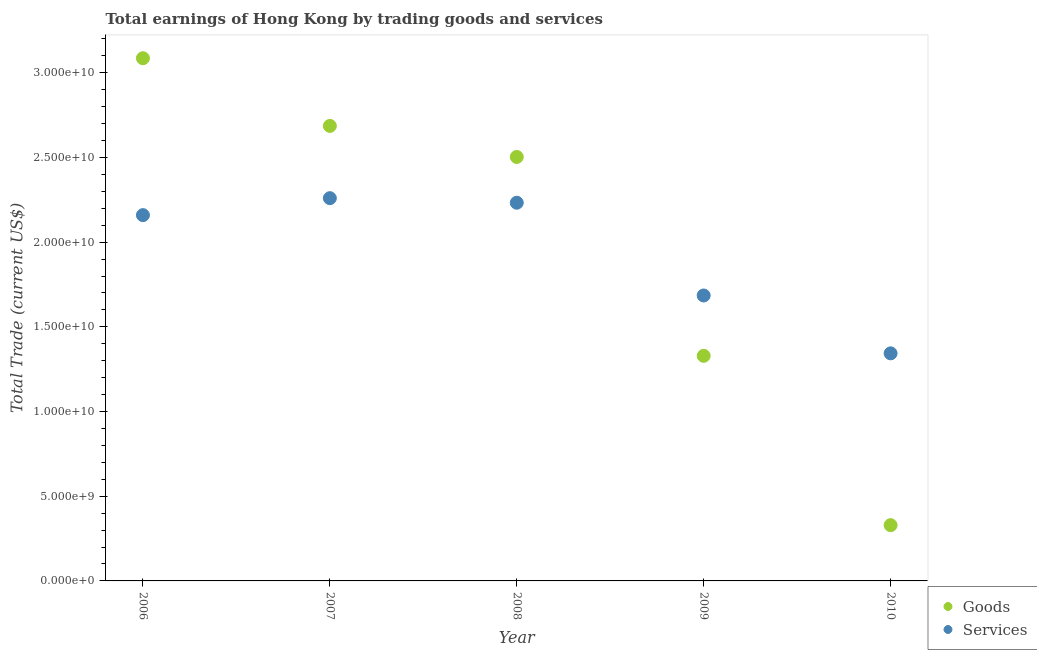What is the amount earned by trading services in 2010?
Your answer should be very brief. 1.34e+1. Across all years, what is the maximum amount earned by trading services?
Keep it short and to the point. 2.26e+1. Across all years, what is the minimum amount earned by trading services?
Your response must be concise. 1.34e+1. In which year was the amount earned by trading goods minimum?
Your answer should be compact. 2010. What is the total amount earned by trading goods in the graph?
Offer a very short reply. 9.93e+1. What is the difference between the amount earned by trading goods in 2008 and that in 2009?
Offer a very short reply. 1.17e+1. What is the difference between the amount earned by trading goods in 2010 and the amount earned by trading services in 2008?
Offer a terse response. -1.90e+1. What is the average amount earned by trading services per year?
Make the answer very short. 1.94e+1. In the year 2007, what is the difference between the amount earned by trading services and amount earned by trading goods?
Ensure brevity in your answer.  -4.27e+09. In how many years, is the amount earned by trading services greater than 5000000000 US$?
Your answer should be compact. 5. What is the ratio of the amount earned by trading goods in 2009 to that in 2010?
Provide a short and direct response. 4.04. What is the difference between the highest and the second highest amount earned by trading goods?
Offer a terse response. 4.00e+09. What is the difference between the highest and the lowest amount earned by trading services?
Provide a short and direct response. 9.16e+09. Is the sum of the amount earned by trading goods in 2008 and 2009 greater than the maximum amount earned by trading services across all years?
Your answer should be compact. Yes. Is the amount earned by trading goods strictly less than the amount earned by trading services over the years?
Keep it short and to the point. No. How many years are there in the graph?
Your response must be concise. 5. What is the difference between two consecutive major ticks on the Y-axis?
Your answer should be compact. 5.00e+09. Does the graph contain grids?
Your response must be concise. No. What is the title of the graph?
Offer a terse response. Total earnings of Hong Kong by trading goods and services. What is the label or title of the Y-axis?
Your response must be concise. Total Trade (current US$). What is the Total Trade (current US$) in Goods in 2006?
Your answer should be compact. 3.09e+1. What is the Total Trade (current US$) in Services in 2006?
Give a very brief answer. 2.16e+1. What is the Total Trade (current US$) in Goods in 2007?
Offer a terse response. 2.69e+1. What is the Total Trade (current US$) in Services in 2007?
Give a very brief answer. 2.26e+1. What is the Total Trade (current US$) in Goods in 2008?
Provide a short and direct response. 2.50e+1. What is the Total Trade (current US$) of Services in 2008?
Make the answer very short. 2.23e+1. What is the Total Trade (current US$) of Goods in 2009?
Make the answer very short. 1.33e+1. What is the Total Trade (current US$) of Services in 2009?
Ensure brevity in your answer.  1.69e+1. What is the Total Trade (current US$) in Goods in 2010?
Offer a terse response. 3.29e+09. What is the Total Trade (current US$) of Services in 2010?
Your answer should be compact. 1.34e+1. Across all years, what is the maximum Total Trade (current US$) of Goods?
Provide a short and direct response. 3.09e+1. Across all years, what is the maximum Total Trade (current US$) in Services?
Offer a very short reply. 2.26e+1. Across all years, what is the minimum Total Trade (current US$) of Goods?
Keep it short and to the point. 3.29e+09. Across all years, what is the minimum Total Trade (current US$) in Services?
Give a very brief answer. 1.34e+1. What is the total Total Trade (current US$) of Goods in the graph?
Give a very brief answer. 9.93e+1. What is the total Total Trade (current US$) of Services in the graph?
Keep it short and to the point. 9.68e+1. What is the difference between the Total Trade (current US$) of Goods in 2006 and that in 2007?
Offer a terse response. 4.00e+09. What is the difference between the Total Trade (current US$) of Services in 2006 and that in 2007?
Offer a very short reply. -1.00e+09. What is the difference between the Total Trade (current US$) of Goods in 2006 and that in 2008?
Offer a very short reply. 5.83e+09. What is the difference between the Total Trade (current US$) in Services in 2006 and that in 2008?
Offer a terse response. -7.32e+08. What is the difference between the Total Trade (current US$) of Goods in 2006 and that in 2009?
Provide a succinct answer. 1.76e+1. What is the difference between the Total Trade (current US$) of Services in 2006 and that in 2009?
Provide a succinct answer. 4.74e+09. What is the difference between the Total Trade (current US$) of Goods in 2006 and that in 2010?
Make the answer very short. 2.76e+1. What is the difference between the Total Trade (current US$) of Services in 2006 and that in 2010?
Offer a terse response. 8.16e+09. What is the difference between the Total Trade (current US$) in Goods in 2007 and that in 2008?
Provide a short and direct response. 1.83e+09. What is the difference between the Total Trade (current US$) of Services in 2007 and that in 2008?
Keep it short and to the point. 2.69e+08. What is the difference between the Total Trade (current US$) of Goods in 2007 and that in 2009?
Provide a succinct answer. 1.36e+1. What is the difference between the Total Trade (current US$) of Services in 2007 and that in 2009?
Offer a terse response. 5.75e+09. What is the difference between the Total Trade (current US$) in Goods in 2007 and that in 2010?
Your response must be concise. 2.36e+1. What is the difference between the Total Trade (current US$) in Services in 2007 and that in 2010?
Provide a short and direct response. 9.16e+09. What is the difference between the Total Trade (current US$) in Goods in 2008 and that in 2009?
Your response must be concise. 1.17e+1. What is the difference between the Total Trade (current US$) of Services in 2008 and that in 2009?
Provide a succinct answer. 5.48e+09. What is the difference between the Total Trade (current US$) in Goods in 2008 and that in 2010?
Provide a short and direct response. 2.17e+1. What is the difference between the Total Trade (current US$) in Services in 2008 and that in 2010?
Offer a very short reply. 8.89e+09. What is the difference between the Total Trade (current US$) of Goods in 2009 and that in 2010?
Your answer should be very brief. 1.00e+1. What is the difference between the Total Trade (current US$) in Services in 2009 and that in 2010?
Your answer should be compact. 3.42e+09. What is the difference between the Total Trade (current US$) of Goods in 2006 and the Total Trade (current US$) of Services in 2007?
Your answer should be very brief. 8.26e+09. What is the difference between the Total Trade (current US$) of Goods in 2006 and the Total Trade (current US$) of Services in 2008?
Offer a very short reply. 8.53e+09. What is the difference between the Total Trade (current US$) in Goods in 2006 and the Total Trade (current US$) in Services in 2009?
Offer a very short reply. 1.40e+1. What is the difference between the Total Trade (current US$) in Goods in 2006 and the Total Trade (current US$) in Services in 2010?
Your answer should be very brief. 1.74e+1. What is the difference between the Total Trade (current US$) in Goods in 2007 and the Total Trade (current US$) in Services in 2008?
Provide a short and direct response. 4.53e+09. What is the difference between the Total Trade (current US$) of Goods in 2007 and the Total Trade (current US$) of Services in 2009?
Ensure brevity in your answer.  1.00e+1. What is the difference between the Total Trade (current US$) of Goods in 2007 and the Total Trade (current US$) of Services in 2010?
Provide a succinct answer. 1.34e+1. What is the difference between the Total Trade (current US$) of Goods in 2008 and the Total Trade (current US$) of Services in 2009?
Give a very brief answer. 8.18e+09. What is the difference between the Total Trade (current US$) in Goods in 2008 and the Total Trade (current US$) in Services in 2010?
Ensure brevity in your answer.  1.16e+1. What is the difference between the Total Trade (current US$) of Goods in 2009 and the Total Trade (current US$) of Services in 2010?
Your answer should be very brief. -1.47e+08. What is the average Total Trade (current US$) of Goods per year?
Give a very brief answer. 1.99e+1. What is the average Total Trade (current US$) in Services per year?
Your answer should be very brief. 1.94e+1. In the year 2006, what is the difference between the Total Trade (current US$) of Goods and Total Trade (current US$) of Services?
Your answer should be compact. 9.26e+09. In the year 2007, what is the difference between the Total Trade (current US$) in Goods and Total Trade (current US$) in Services?
Provide a short and direct response. 4.27e+09. In the year 2008, what is the difference between the Total Trade (current US$) of Goods and Total Trade (current US$) of Services?
Offer a very short reply. 2.70e+09. In the year 2009, what is the difference between the Total Trade (current US$) of Goods and Total Trade (current US$) of Services?
Your answer should be compact. -3.56e+09. In the year 2010, what is the difference between the Total Trade (current US$) in Goods and Total Trade (current US$) in Services?
Offer a terse response. -1.01e+1. What is the ratio of the Total Trade (current US$) of Goods in 2006 to that in 2007?
Offer a very short reply. 1.15. What is the ratio of the Total Trade (current US$) in Services in 2006 to that in 2007?
Offer a very short reply. 0.96. What is the ratio of the Total Trade (current US$) of Goods in 2006 to that in 2008?
Provide a short and direct response. 1.23. What is the ratio of the Total Trade (current US$) of Services in 2006 to that in 2008?
Give a very brief answer. 0.97. What is the ratio of the Total Trade (current US$) in Goods in 2006 to that in 2009?
Provide a succinct answer. 2.32. What is the ratio of the Total Trade (current US$) in Services in 2006 to that in 2009?
Ensure brevity in your answer.  1.28. What is the ratio of the Total Trade (current US$) in Goods in 2006 to that in 2010?
Give a very brief answer. 9.37. What is the ratio of the Total Trade (current US$) of Services in 2006 to that in 2010?
Give a very brief answer. 1.61. What is the ratio of the Total Trade (current US$) in Goods in 2007 to that in 2008?
Offer a very short reply. 1.07. What is the ratio of the Total Trade (current US$) in Services in 2007 to that in 2008?
Offer a very short reply. 1.01. What is the ratio of the Total Trade (current US$) of Goods in 2007 to that in 2009?
Offer a terse response. 2.02. What is the ratio of the Total Trade (current US$) of Services in 2007 to that in 2009?
Make the answer very short. 1.34. What is the ratio of the Total Trade (current US$) of Goods in 2007 to that in 2010?
Ensure brevity in your answer.  8.16. What is the ratio of the Total Trade (current US$) in Services in 2007 to that in 2010?
Ensure brevity in your answer.  1.68. What is the ratio of the Total Trade (current US$) in Goods in 2008 to that in 2009?
Make the answer very short. 1.88. What is the ratio of the Total Trade (current US$) in Services in 2008 to that in 2009?
Keep it short and to the point. 1.32. What is the ratio of the Total Trade (current US$) in Goods in 2008 to that in 2010?
Keep it short and to the point. 7.6. What is the ratio of the Total Trade (current US$) in Services in 2008 to that in 2010?
Your answer should be very brief. 1.66. What is the ratio of the Total Trade (current US$) of Goods in 2009 to that in 2010?
Offer a terse response. 4.04. What is the ratio of the Total Trade (current US$) of Services in 2009 to that in 2010?
Your answer should be compact. 1.25. What is the difference between the highest and the second highest Total Trade (current US$) of Goods?
Provide a short and direct response. 4.00e+09. What is the difference between the highest and the second highest Total Trade (current US$) of Services?
Provide a short and direct response. 2.69e+08. What is the difference between the highest and the lowest Total Trade (current US$) of Goods?
Offer a terse response. 2.76e+1. What is the difference between the highest and the lowest Total Trade (current US$) in Services?
Give a very brief answer. 9.16e+09. 